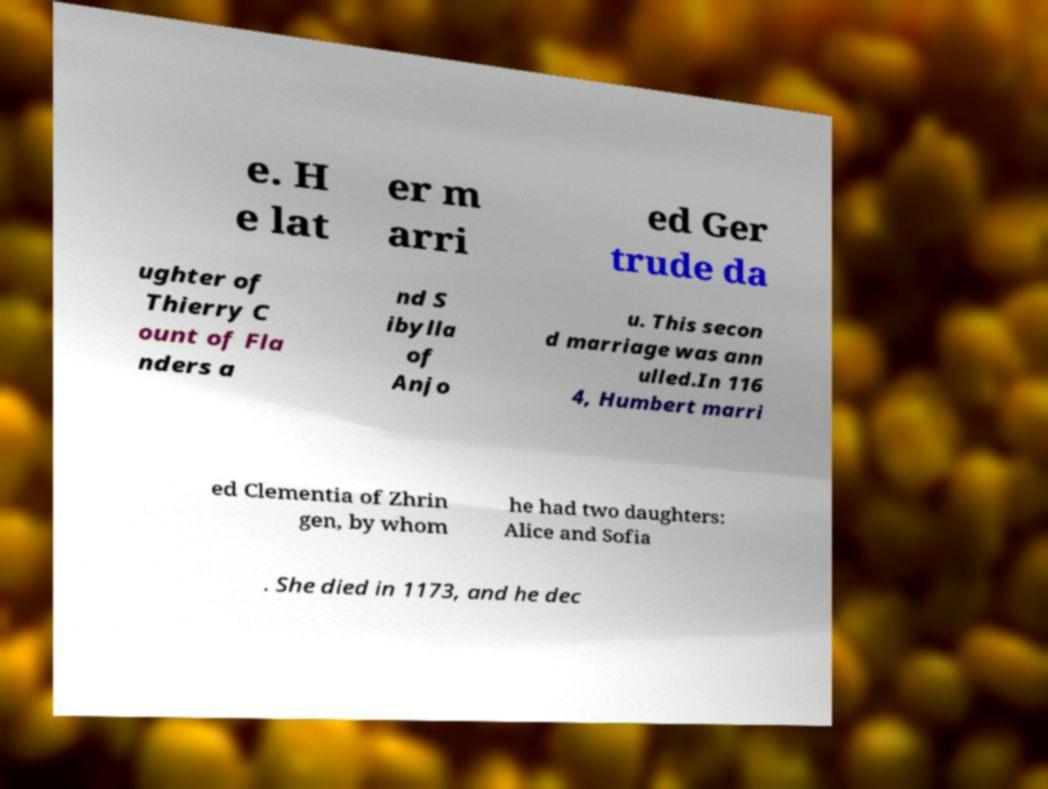I need the written content from this picture converted into text. Can you do that? e. H e lat er m arri ed Ger trude da ughter of Thierry C ount of Fla nders a nd S ibylla of Anjo u. This secon d marriage was ann ulled.In 116 4, Humbert marri ed Clementia of Zhrin gen, by whom he had two daughters: Alice and Sofia . She died in 1173, and he dec 